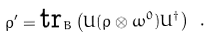Convert formula to latex. <formula><loc_0><loc_0><loc_500><loc_500>\rho ^ { \prime } = \text {tr} _ { B } \left ( U ( \rho \otimes \omega ^ { 0 } ) U ^ { \dagger } \right ) \ .</formula> 